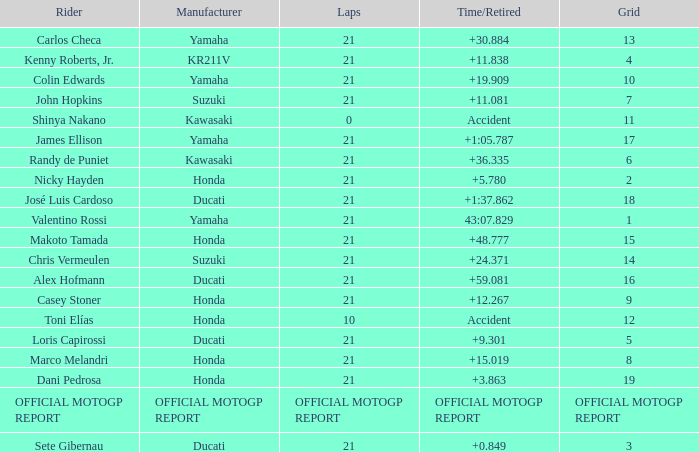When rider John Hopkins had 21 laps, what was the grid? 7.0. 